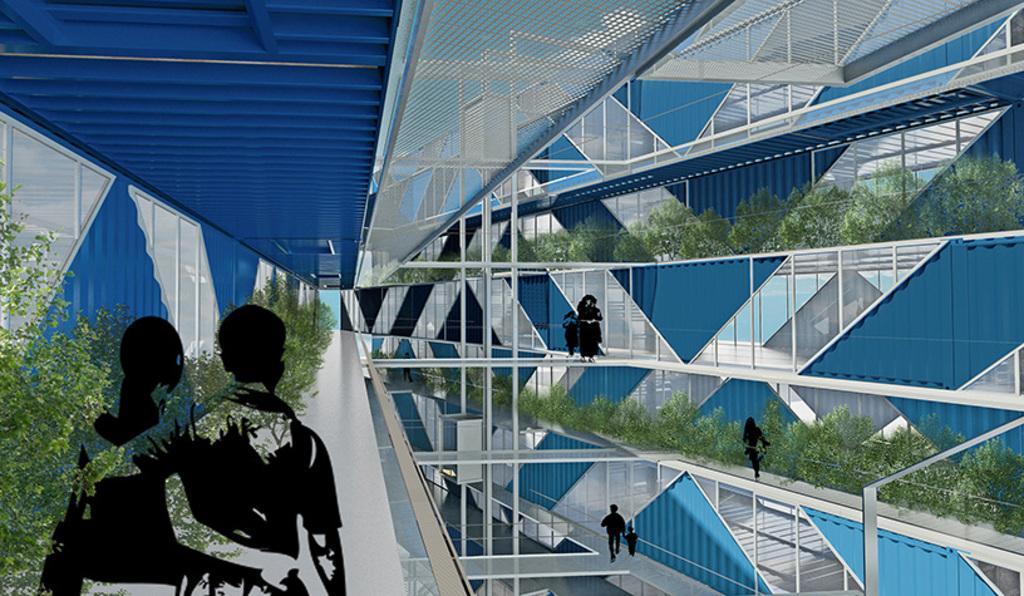Please provide a concise description of this image. In this picture we can see inside view of a building, where we can see people, plants on the floor and in the background we can see a roof. 